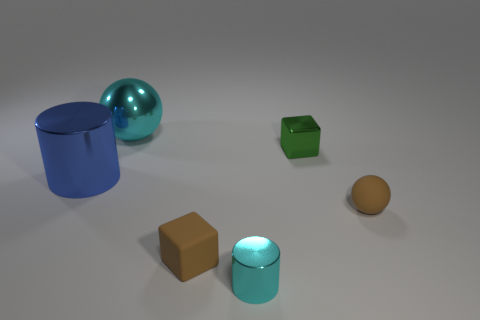Is there anything else of the same color as the large metallic cylinder?
Offer a very short reply. No. How many objects are big green cubes or brown objects that are right of the tiny green shiny block?
Your answer should be compact. 1. The brown object that is left of the ball that is on the right side of the cyan metallic object behind the big blue metal cylinder is made of what material?
Your answer should be very brief. Rubber. There is a cyan sphere that is made of the same material as the big blue thing; what size is it?
Provide a succinct answer. Large. The ball left of the cylinder that is right of the cyan ball is what color?
Provide a succinct answer. Cyan. What number of large green cylinders are the same material as the blue object?
Offer a terse response. 0. What number of rubber objects are tiny green cubes or small brown things?
Offer a very short reply. 2. There is another block that is the same size as the matte block; what is it made of?
Your answer should be compact. Metal. Is there a blue object that has the same material as the big cylinder?
Offer a terse response. No. What shape is the cyan metal thing that is behind the cylinder right of the big object left of the metallic ball?
Keep it short and to the point. Sphere. 